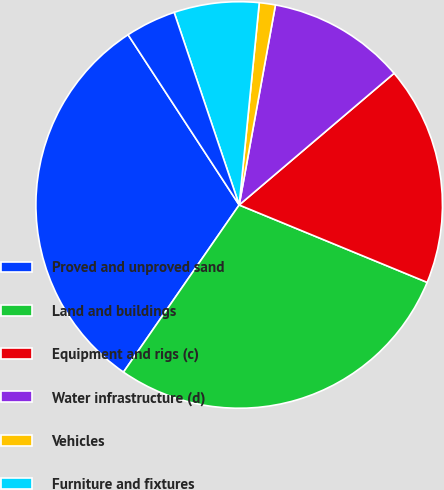Convert chart to OTSL. <chart><loc_0><loc_0><loc_500><loc_500><pie_chart><fcel>Proved and unproved sand<fcel>Land and buildings<fcel>Equipment and rigs (c)<fcel>Water infrastructure (d)<fcel>Vehicles<fcel>Furniture and fixtures<fcel>Leasehold improvements<nl><fcel>31.16%<fcel>28.42%<fcel>17.43%<fcel>10.93%<fcel>1.28%<fcel>6.76%<fcel>4.02%<nl></chart> 